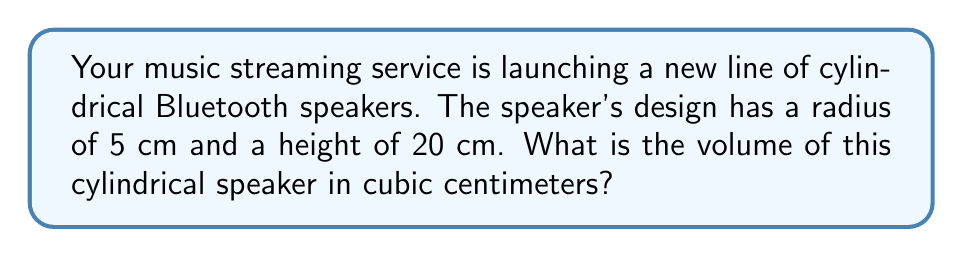Can you answer this question? To solve this problem, we'll use the formula for the volume of a cylinder:

$$V = \pi r^2 h$$

Where:
$V$ = volume
$r$ = radius of the base
$h$ = height of the cylinder

Given:
$r = 5$ cm
$h = 20$ cm

Let's substitute these values into the formula:

$$V = \pi (5 \text{ cm})^2 (20 \text{ cm})$$

Simplify:
$$V = \pi (25 \text{ cm}^2) (20 \text{ cm})$$
$$V = 500\pi \text{ cm}^3$$

Calculate the final value (rounded to the nearest whole number):
$$V \approx 1,571 \text{ cm}^3$$

[asy]
import geometry;

size(200);
real r = 5;
real h = 20;
path base = circle((0,0), r);
path top = circle((0,h), r);
draw(base);
draw(top);
draw((r,0)--(r,h));
draw((-r,0)--(-r,h));
label("r = 5 cm", (r/2,-2), E);
label("h = 20 cm", (r+1,h/2), E);
[/asy]
Answer: $1,571 \text{ cm}^3$ 